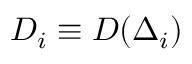<formula> <loc_0><loc_0><loc_500><loc_500>D _ { i } \equiv D ( \Delta _ { i } )</formula> 